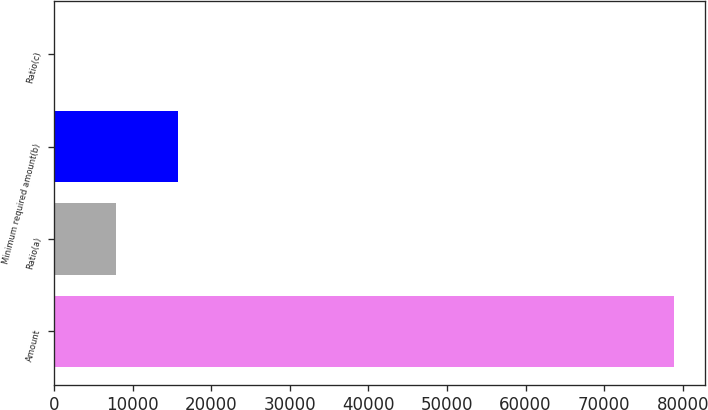Convert chart to OTSL. <chart><loc_0><loc_0><loc_500><loc_500><bar_chart><fcel>Amount<fcel>Ratio(a)<fcel>Minimum required amount(b)<fcel>Ratio(c)<nl><fcel>78908<fcel>7909.92<fcel>15798.6<fcel>21.24<nl></chart> 